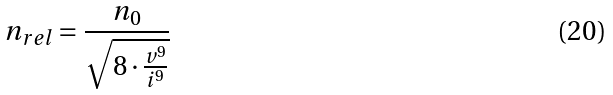Convert formula to latex. <formula><loc_0><loc_0><loc_500><loc_500>n _ { r e l } = \frac { n _ { 0 } } { \sqrt { 8 \cdot \frac { v ^ { 9 } } { i ^ { 9 } } } }</formula> 